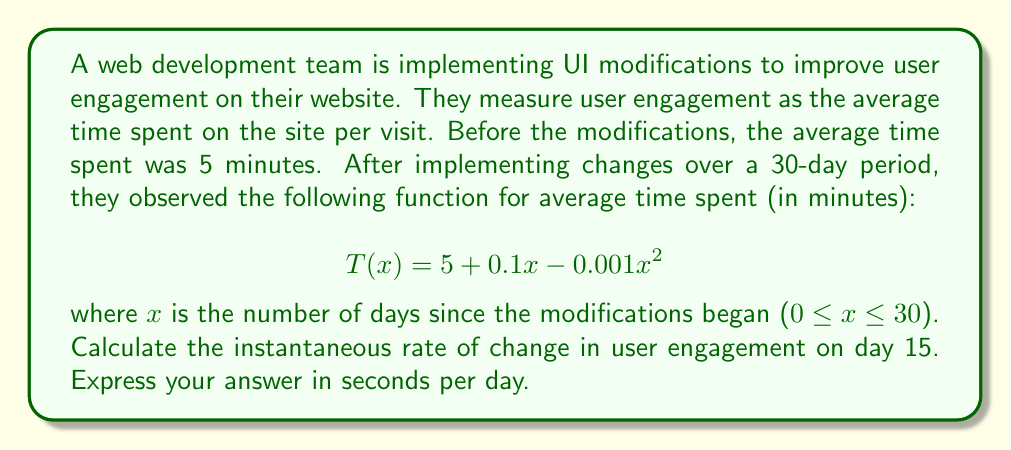Provide a solution to this math problem. To solve this problem, we need to find the derivative of the function T(x) and evaluate it at x = 15. This will give us the instantaneous rate of change on day 15.

1. First, let's find the derivative of T(x):
   $$T(x) = 5 + 0.1x - 0.001x^2$$
   $$T'(x) = 0.1 - 0.002x$$

2. Now, we evaluate T'(x) at x = 15:
   $$T'(15) = 0.1 - 0.002(15) = 0.1 - 0.03 = 0.07$$

3. This result is in minutes per day. To convert it to seconds per day, we multiply by 60:
   $$0.07 \text{ minutes/day} \times 60 \text{ seconds/minute} = 4.2 \text{ seconds/day}$$

The positive value indicates that user engagement is still increasing on day 15, but at a slower rate than at the beginning of the modifications (when x = 0 and T'(0) = 0.1 minutes/day or 6 seconds/day).

This type of analysis is similar to how a web developer might use jQuery to track user interactions and calculate performance metrics in real-time, or how an MVC architecture might separate the data model (the engagement function) from the view (UI modifications) and controller (analysis of engagement rates).
Answer: 4.2 seconds per day 